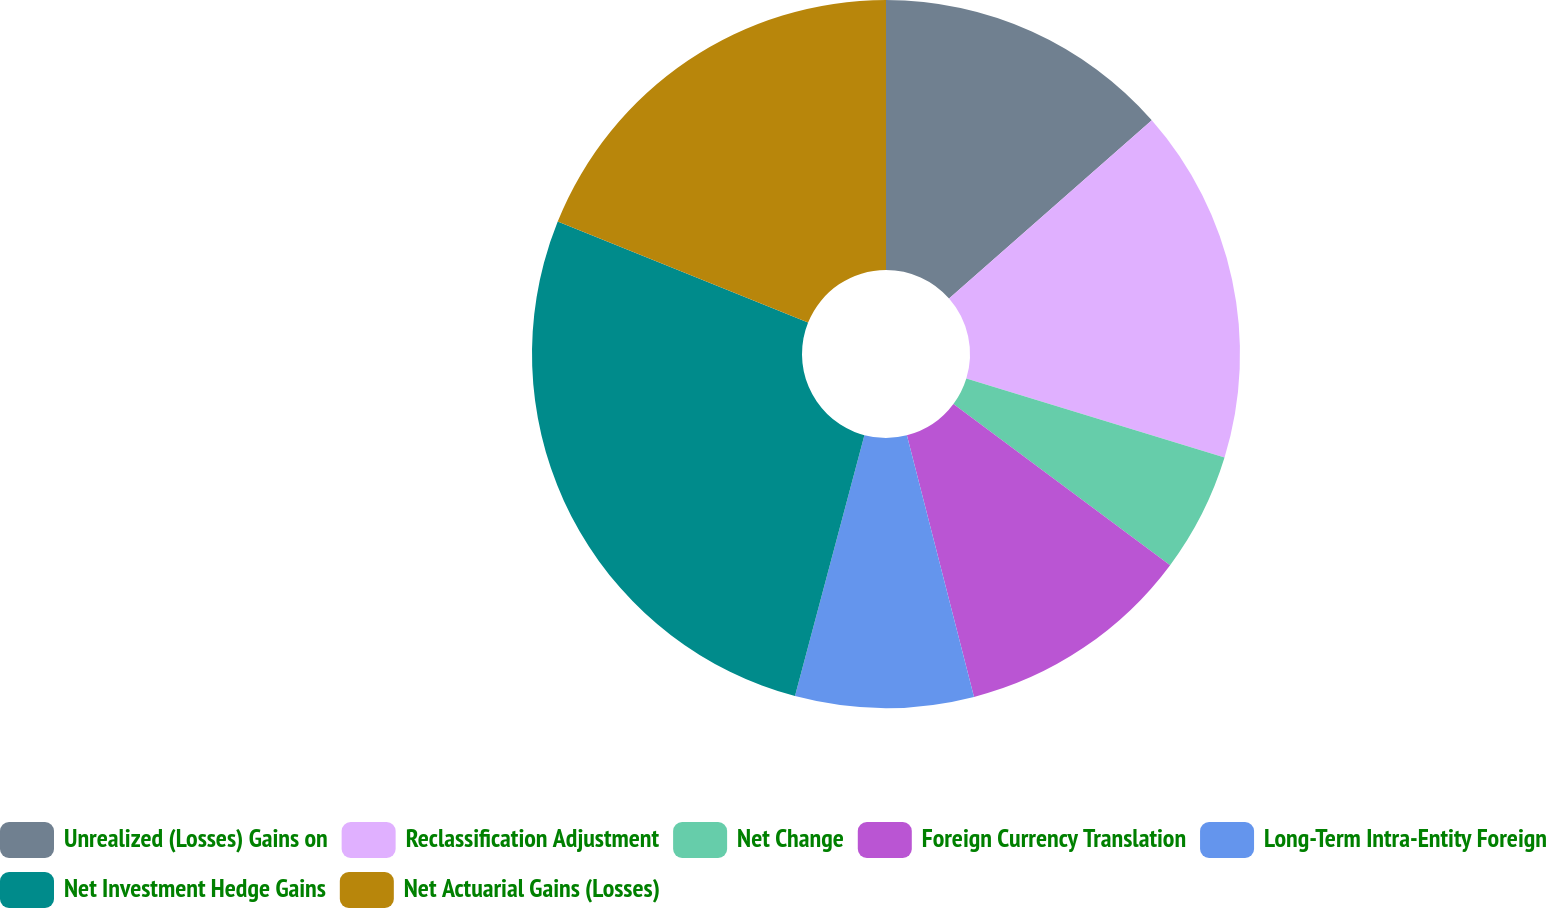<chart> <loc_0><loc_0><loc_500><loc_500><pie_chart><fcel>Unrealized (Losses) Gains on<fcel>Reclassification Adjustment<fcel>Net Change<fcel>Foreign Currency Translation<fcel>Long-Term Intra-Entity Foreign<fcel>Net Investment Hedge Gains<fcel>Net Actuarial Gains (Losses)<nl><fcel>13.52%<fcel>16.21%<fcel>5.45%<fcel>10.83%<fcel>8.14%<fcel>26.97%<fcel>18.9%<nl></chart> 